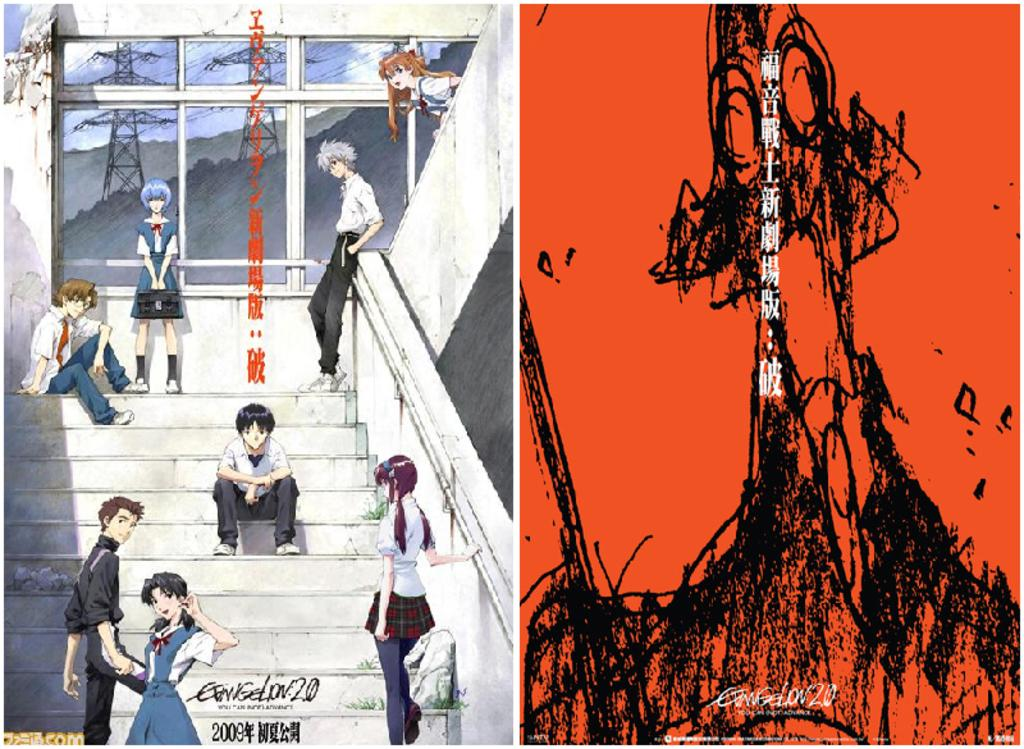Provide a one-sentence caption for the provided image. Anime sitting on some steps with the word Evangelion on the bottom. 